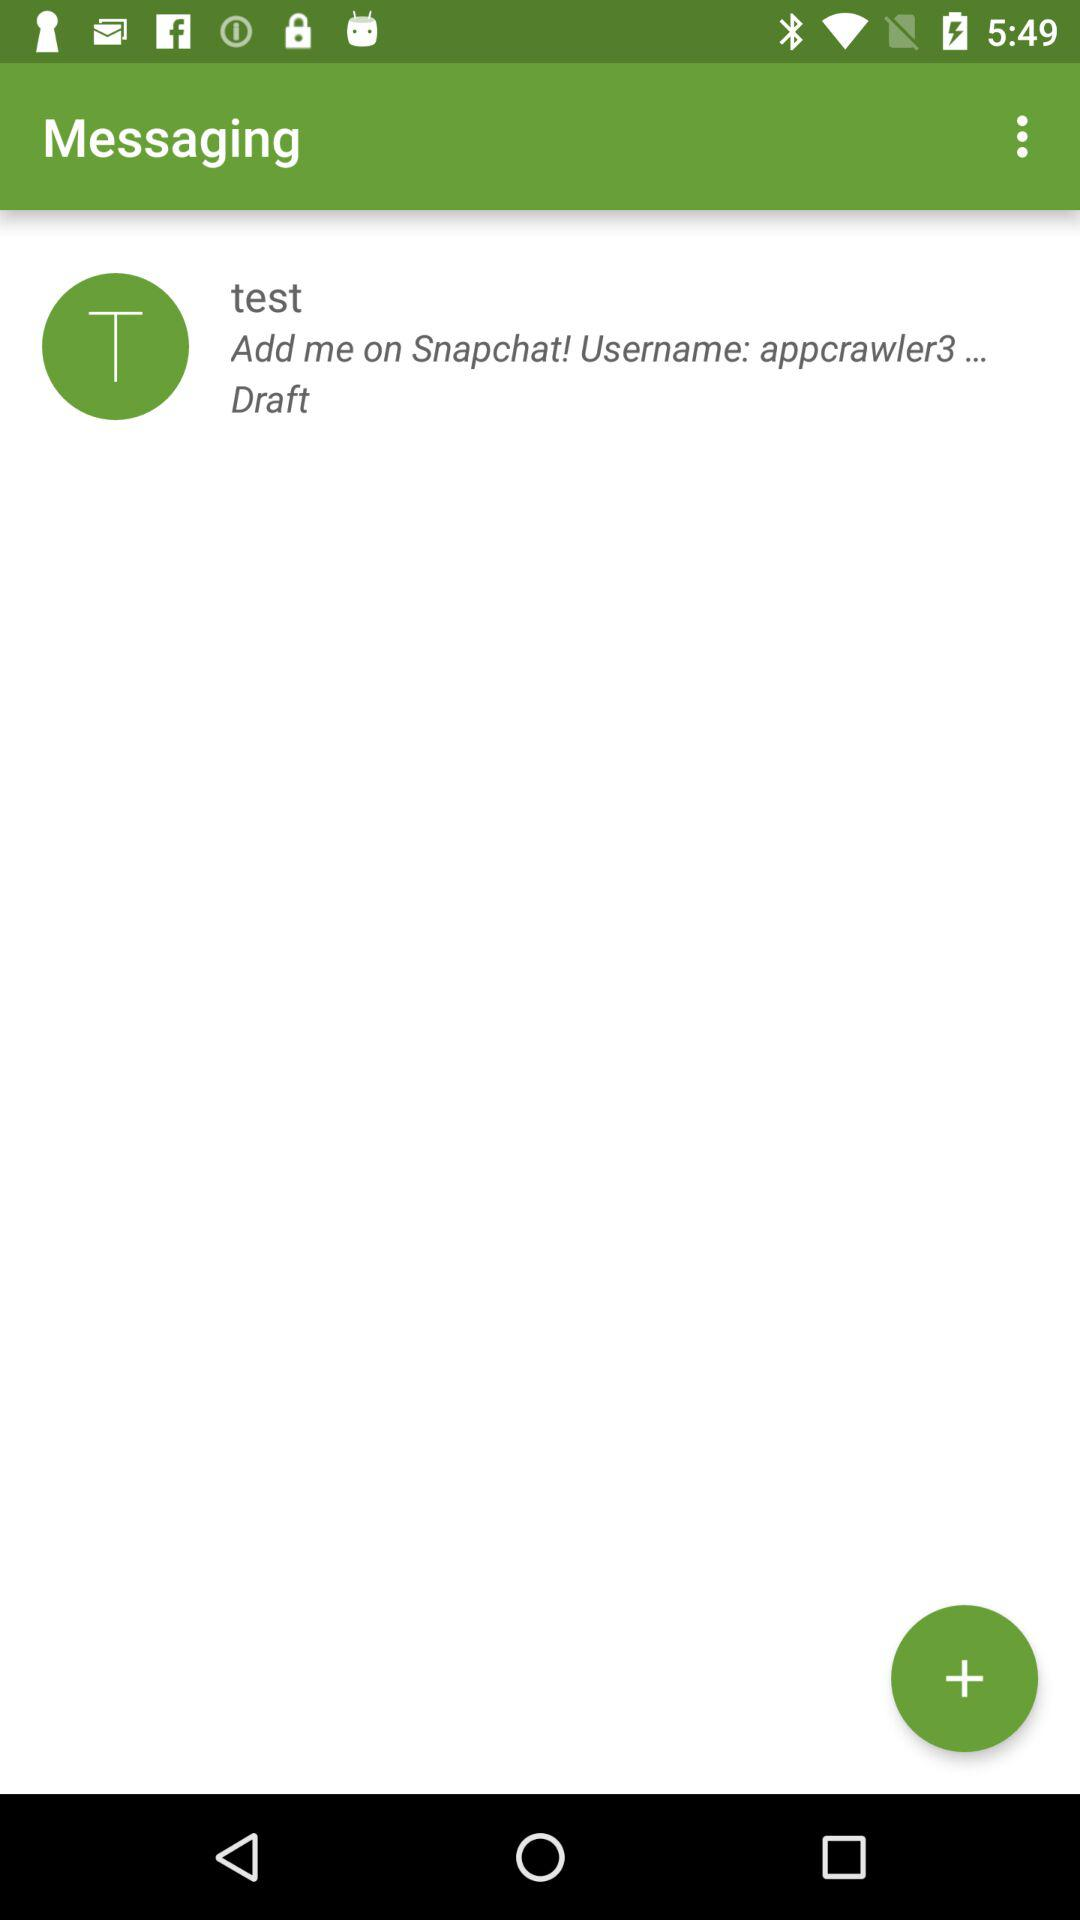What's the username? The username is "appcrawler3...". 